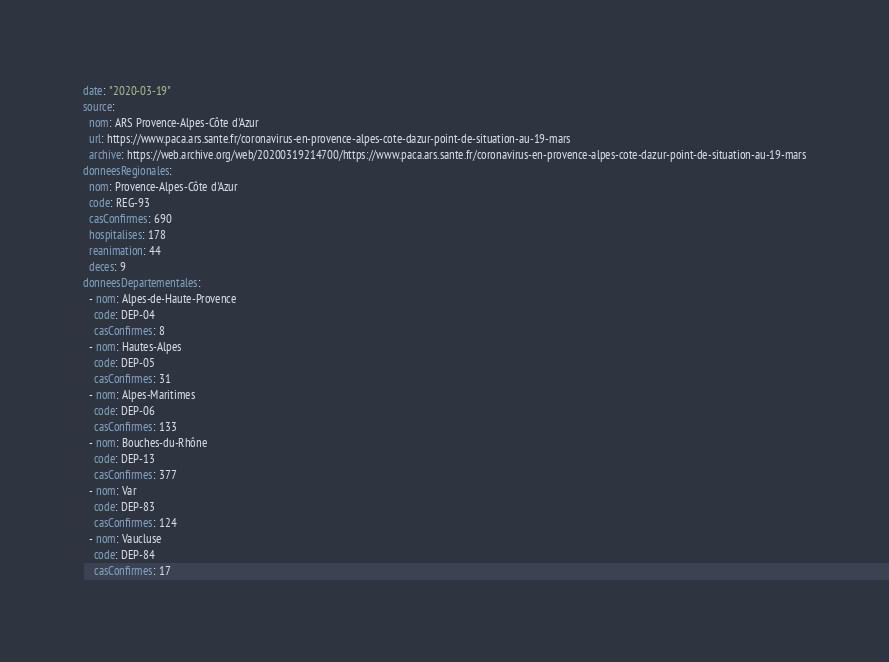<code> <loc_0><loc_0><loc_500><loc_500><_YAML_>date: "2020-03-19"
source:
  nom: ARS Provence-Alpes-Côte d'Azur
  url: https://www.paca.ars.sante.fr/coronavirus-en-provence-alpes-cote-dazur-point-de-situation-au-19-mars
  archive: https://web.archive.org/web/20200319214700/https://www.paca.ars.sante.fr/coronavirus-en-provence-alpes-cote-dazur-point-de-situation-au-19-mars
donneesRegionales:
  nom: Provence-Alpes-Côte d'Azur
  code: REG-93
  casConfirmes: 690
  hospitalises: 178
  reanimation: 44
  deces: 9
donneesDepartementales:
  - nom: Alpes-de-Haute-Provence
    code: DEP-04
    casConfirmes: 8
  - nom: Hautes-Alpes
    code: DEP-05
    casConfirmes: 31
  - nom: Alpes-Maritimes
    code: DEP-06
    casConfirmes: 133
  - nom: Bouches-du-Rhône
    code: DEP-13
    casConfirmes: 377
  - nom: Var
    code: DEP-83
    casConfirmes: 124
  - nom: Vaucluse
    code: DEP-84
    casConfirmes: 17
</code> 